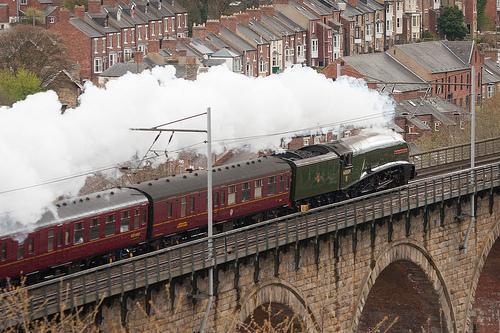How many cars are there?
Give a very brief answer. 3. How many green cars?
Give a very brief answer. 1. 